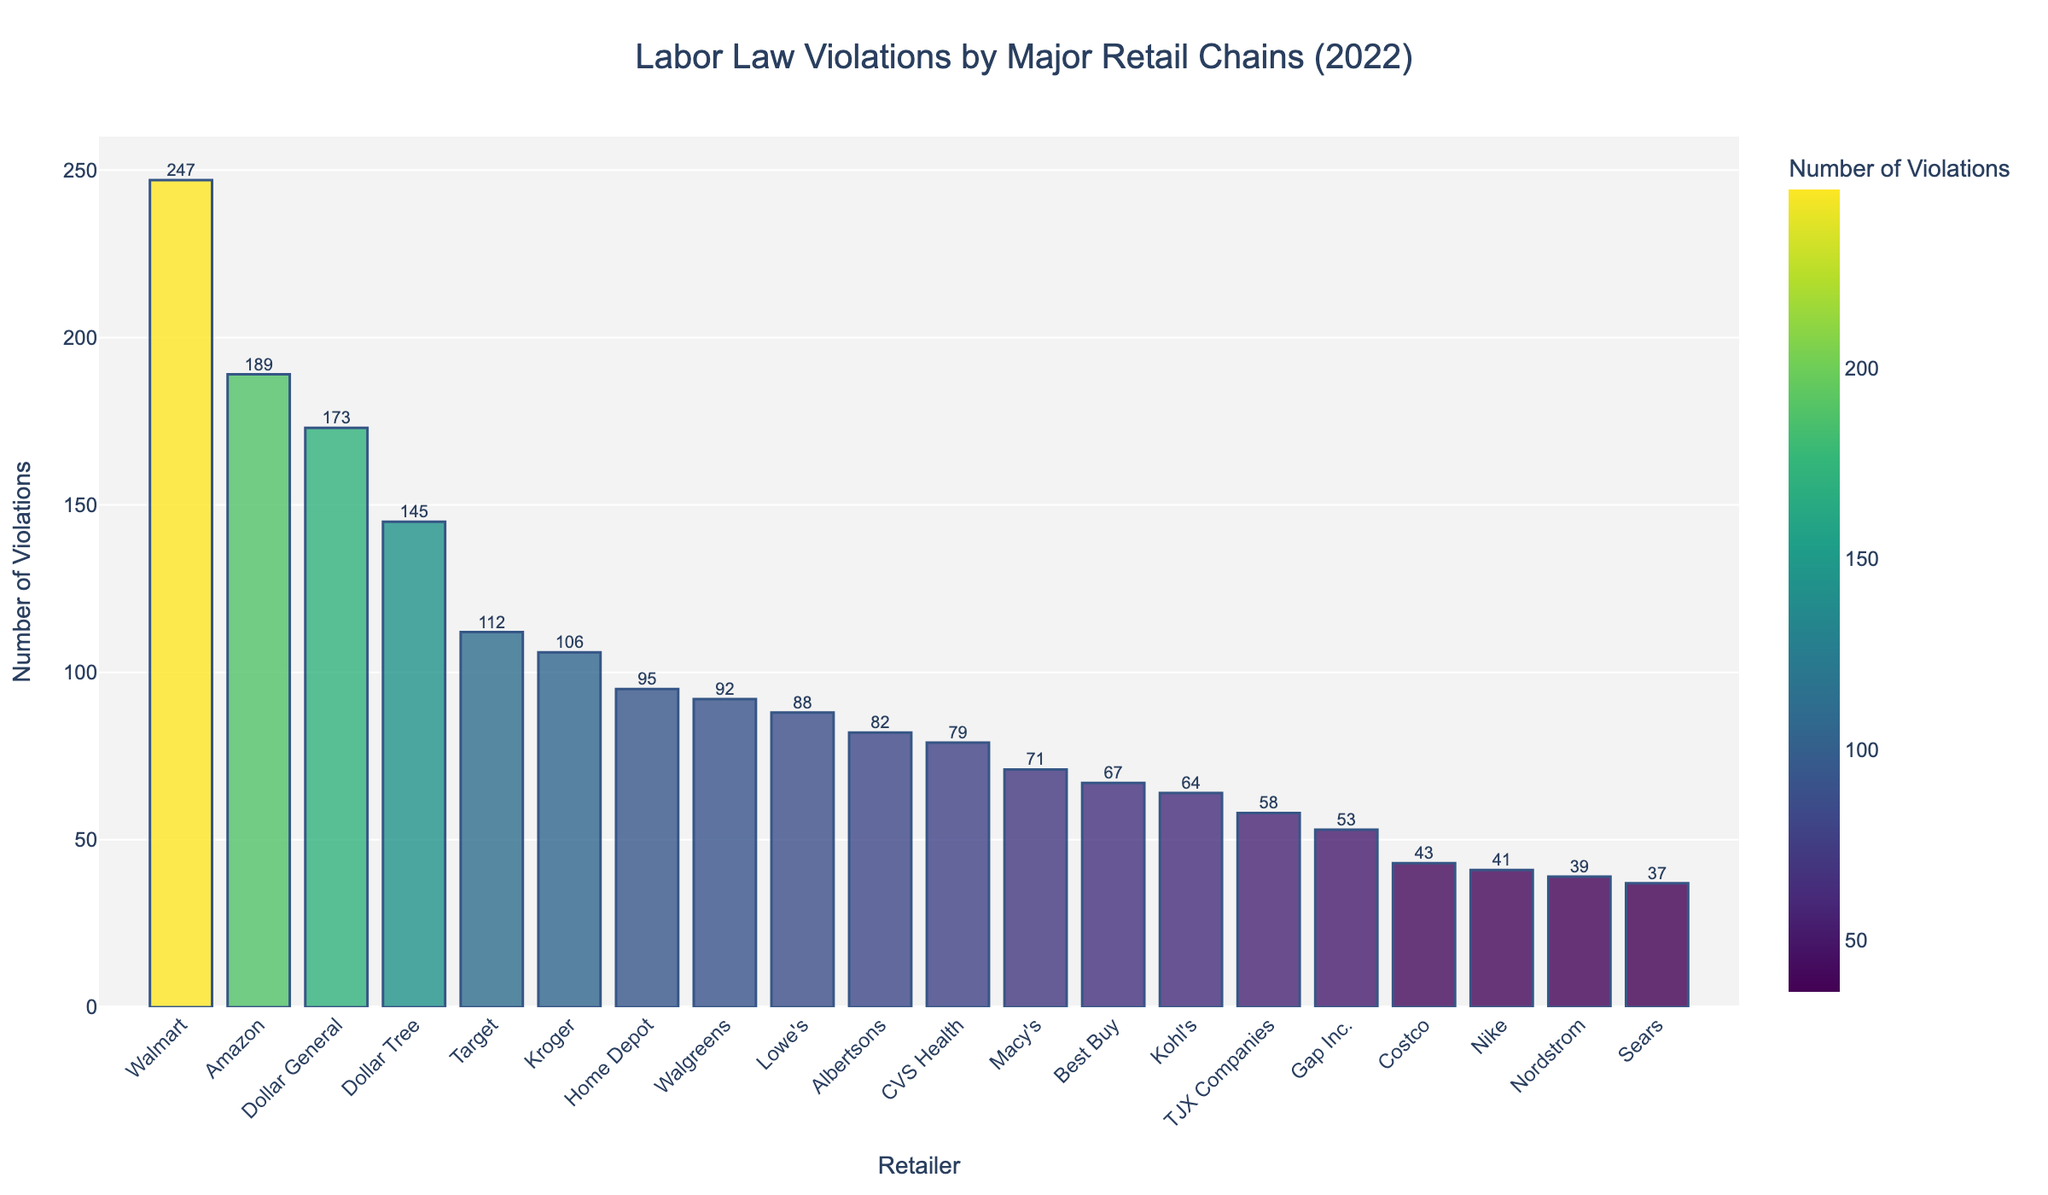Which retailer had the highest number of labor law violations in 2022? The bar chart shows a comparison of labor law violations among major retail chains in 2022, and the highest bar represents Walmart.
Answer: Walmart Which retailer had the lowest number of labor law violations in 2022? The bar chart shows the number of violations for each retailer, with the lowest bar representing Sears.
Answer: Sears How many more labor law violations did Walmart have compared to Amazon in 2022? Walmart had 247 violations and Amazon had 189. The difference is 247 - 189 = 58.
Answer: 58 What's the average number of labor law violations among all the retail chains? Add up all the violations (247 + 189 + 112 + 43 + 95 + 88 + 67 + 173 + 79 + 106 + 92 + 58 + 71 + 53 + 41 + 64 + 39 + 82 + 145 + 37) = 1681, then divide by the number of retailers (20). The average is 1681 / 20 = 84.05.
Answer: 84.05 Which retailer ranks third in terms of labor law violations in 2022? The third highest bar on the chart represents Dollar General.
Answer: Dollar General What is the combined total of labor law violations for Walmart, Amazon, and Dollar General in 2022? Sum the violations of Walmart (247), Amazon (189), and Dollar General (173). The combined total is 247 + 189 + 173 = 609.
Answer: 609 How does the number of violations by Costco compare to those by Target? Costco had 43 violations and Target had 112. 112 is greater than 43.
Answer: Target has more violations Which two retailers had violations in the 40s? The bars in the range of 40s represent Costco (43) and Nike (41).
Answer: Costco and Nike What is the median number of labor law violations among the retailers? First, list the numbers of violations in ascending order: 37, 39, 41, 43, 53, 58, 64, 67, 71, 79, 82, 88, 92, 95, 106, 112, 145, 173, 189, 247. Since there are 20 data points, the median is the average of the 10th and 11th values: (79 + 82) / 2 = 80.5.
Answer: 80.5 